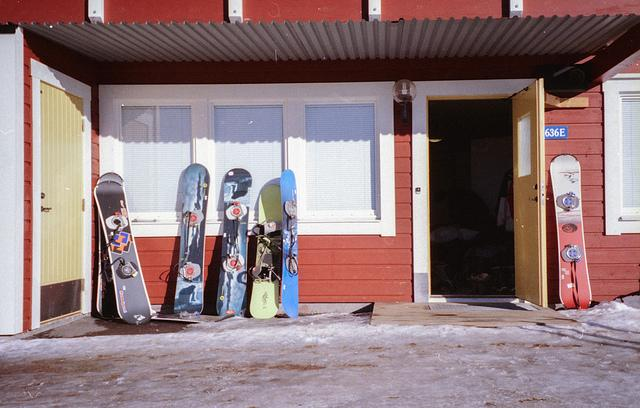What activity are the boards lined up against the building used for? snowboarding 